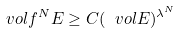Convert formula to latex. <formula><loc_0><loc_0><loc_500><loc_500>\ v o l f ^ { N } E \geq C ( \ v o l E ) ^ { \lambda ^ { N } }</formula> 